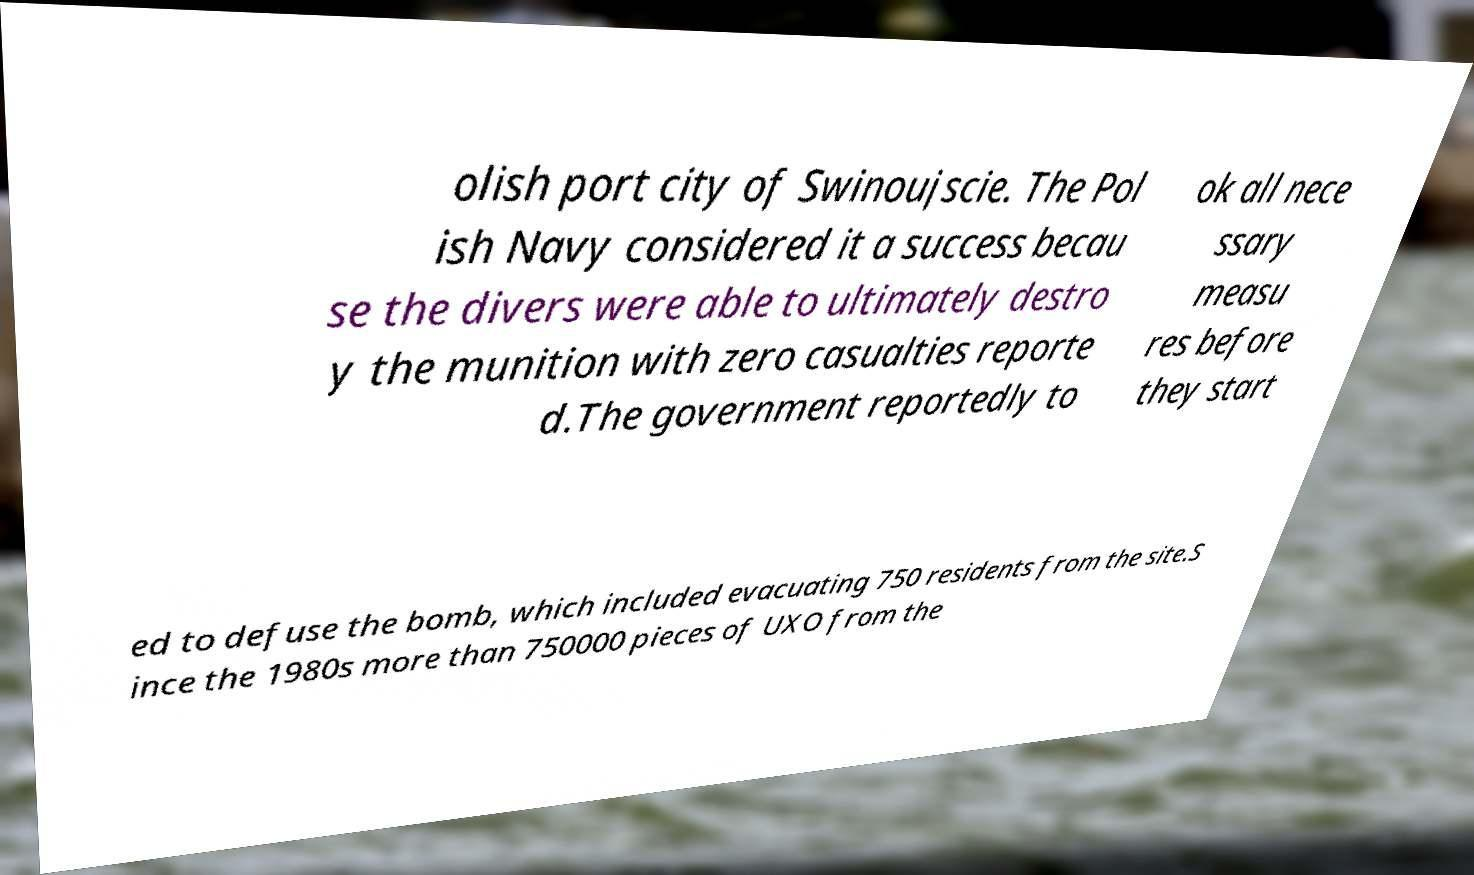For documentation purposes, I need the text within this image transcribed. Could you provide that? olish port city of Swinoujscie. The Pol ish Navy considered it a success becau se the divers were able to ultimately destro y the munition with zero casualties reporte d.The government reportedly to ok all nece ssary measu res before they start ed to defuse the bomb, which included evacuating 750 residents from the site.S ince the 1980s more than 750000 pieces of UXO from the 